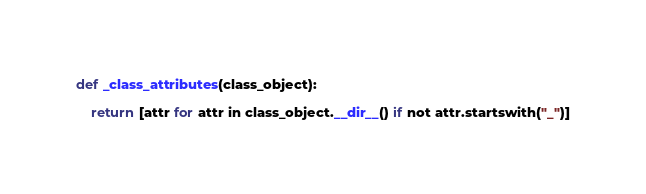Convert code to text. <code><loc_0><loc_0><loc_500><loc_500><_Python_>def _class_attributes(class_object):

    return [attr for attr in class_object.__dir__() if not attr.startswith("_")]</code> 